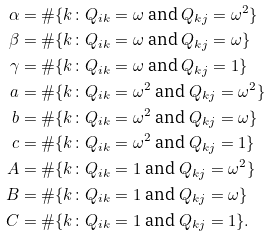<formula> <loc_0><loc_0><loc_500><loc_500>\alpha & = \# \{ k \colon Q _ { i k } = \omega \text { and } Q _ { k j } = \omega ^ { 2 } \} \\ \beta & = \# \{ k \colon Q _ { i k } = \omega \text { and } Q _ { k j } = \omega \} \\ \gamma & = \# \{ k \colon Q _ { i k } = \omega \text { and } Q _ { k j } = 1 \} \\ a & = \# \{ k \colon Q _ { i k } = \omega ^ { 2 } \text { and } Q _ { k j } = \omega ^ { 2 } \} \\ b & = \# \{ k \colon Q _ { i k } = \omega ^ { 2 } \text { and } Q _ { k j } = \omega \} \\ c & = \# \{ k \colon Q _ { i k } = \omega ^ { 2 } \text { and } Q _ { k j } = 1 \} \\ A & = \# \{ k \colon Q _ { i k } = 1 \text { and } Q _ { k j } = \omega ^ { 2 } \} \\ B & = \# \{ k \colon Q _ { i k } = 1 \text { and } Q _ { k j } = \omega \} \\ C & = \# \{ k \colon Q _ { i k } = 1 \text { and } Q _ { k j } = 1 \} .</formula> 